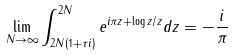Convert formula to latex. <formula><loc_0><loc_0><loc_500><loc_500>\lim _ { N \to \infty } \int _ { 2 N ( 1 + \tau i ) } ^ { 2 N } e ^ { i \pi z + \log z / z } d z = - \frac { i } { \pi }</formula> 